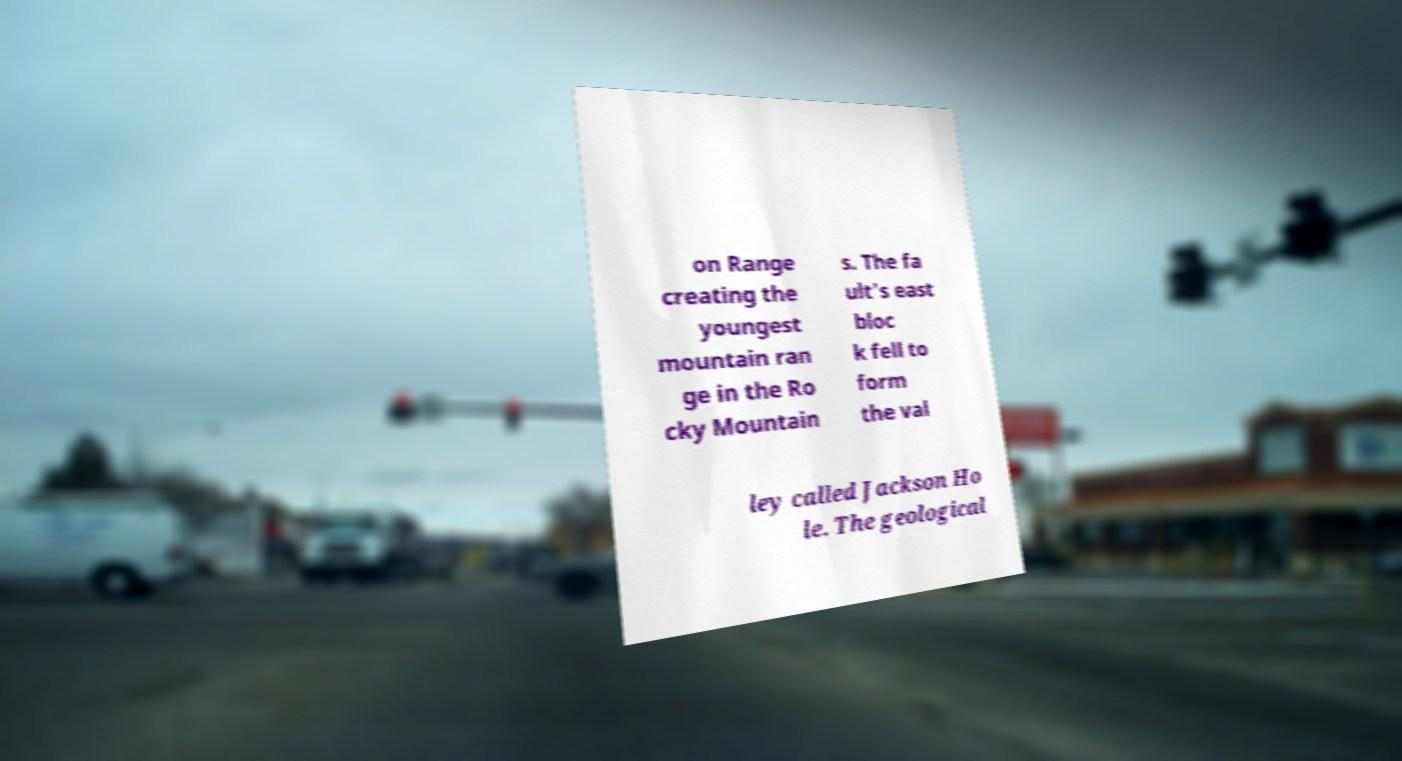Please read and relay the text visible in this image. What does it say? on Range creating the youngest mountain ran ge in the Ro cky Mountain s. The fa ult's east bloc k fell to form the val ley called Jackson Ho le. The geological 